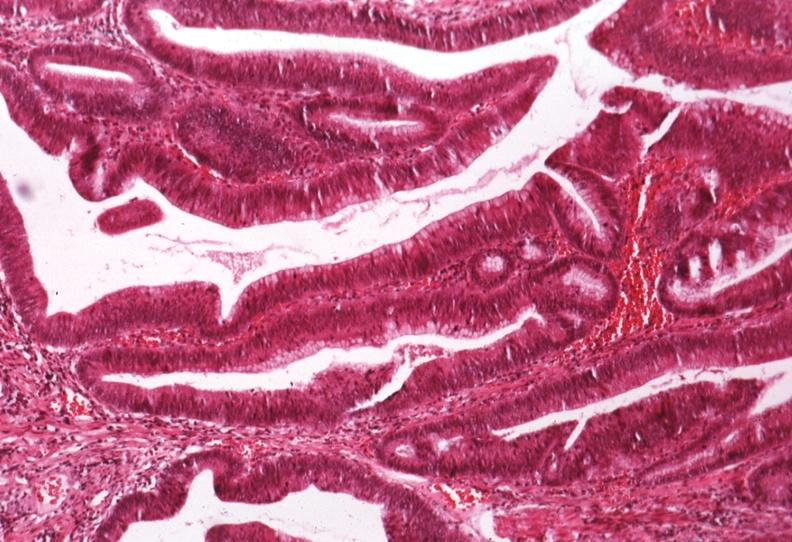where is this from?
Answer the question using a single word or phrase. Gastrointestinal system 